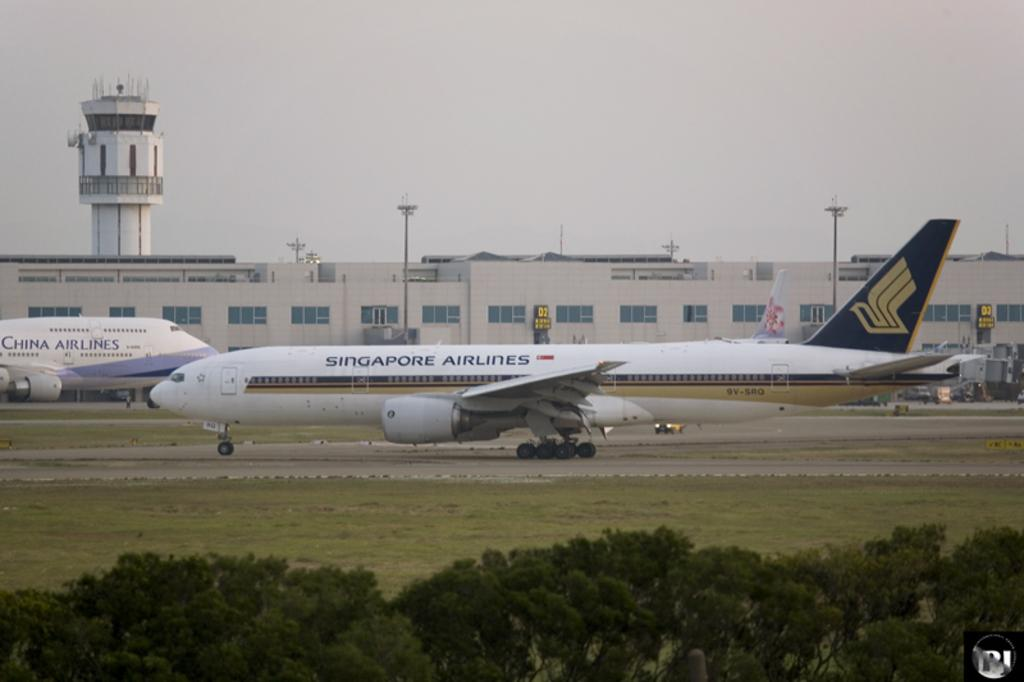<image>
Write a terse but informative summary of the picture. A plane from China Airlines and a plane from Singapore Airlines heading in opposite directions. 